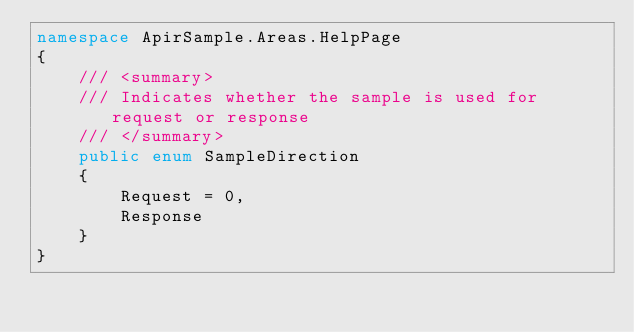Convert code to text. <code><loc_0><loc_0><loc_500><loc_500><_C#_>namespace ApirSample.Areas.HelpPage
{
    /// <summary>
    /// Indicates whether the sample is used for request or response
    /// </summary>
    public enum SampleDirection
    {
        Request = 0,
        Response
    }
}</code> 